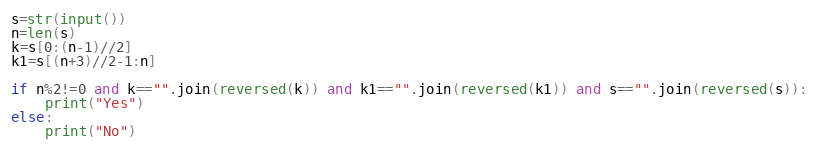Convert code to text. <code><loc_0><loc_0><loc_500><loc_500><_Python_>s=str(input())
n=len(s)
k=s[0:(n-1)//2]
k1=s[(n+3)//2-1:n]

if n%2!=0 and k=="".join(reversed(k)) and k1=="".join(reversed(k1)) and s=="".join(reversed(s)):
    print("Yes")
else:
    print("No")</code> 